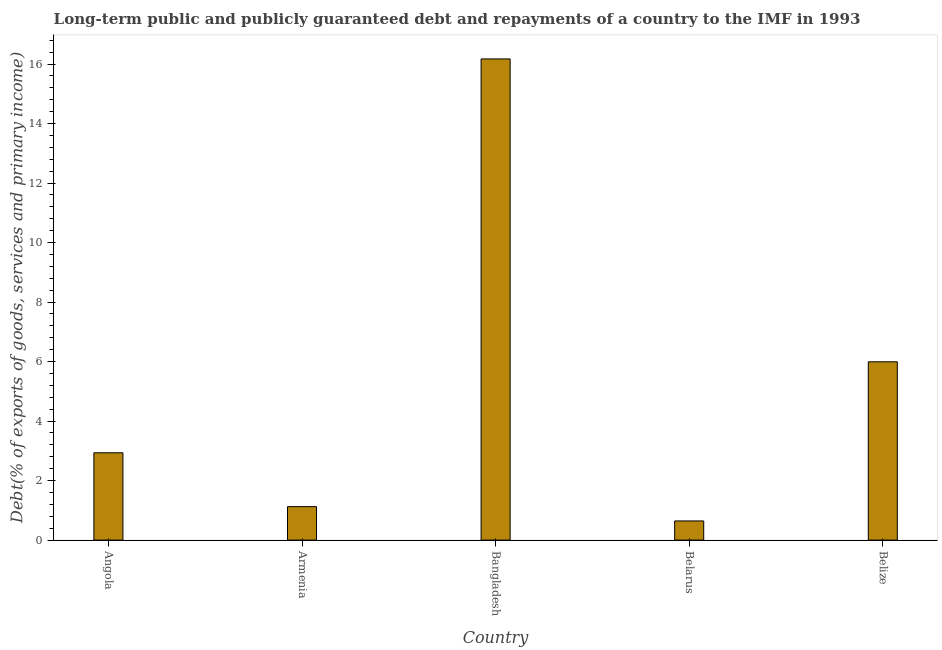What is the title of the graph?
Keep it short and to the point. Long-term public and publicly guaranteed debt and repayments of a country to the IMF in 1993. What is the label or title of the X-axis?
Offer a very short reply. Country. What is the label or title of the Y-axis?
Your answer should be very brief. Debt(% of exports of goods, services and primary income). What is the debt service in Belarus?
Give a very brief answer. 0.64. Across all countries, what is the maximum debt service?
Make the answer very short. 16.17. Across all countries, what is the minimum debt service?
Your answer should be compact. 0.64. In which country was the debt service minimum?
Provide a succinct answer. Belarus. What is the sum of the debt service?
Provide a succinct answer. 26.87. What is the difference between the debt service in Armenia and Belize?
Provide a short and direct response. -4.87. What is the average debt service per country?
Make the answer very short. 5.37. What is the median debt service?
Your response must be concise. 2.93. What is the ratio of the debt service in Angola to that in Belize?
Ensure brevity in your answer.  0.49. Is the debt service in Angola less than that in Armenia?
Offer a terse response. No. What is the difference between the highest and the second highest debt service?
Provide a short and direct response. 10.18. Is the sum of the debt service in Angola and Armenia greater than the maximum debt service across all countries?
Give a very brief answer. No. What is the difference between the highest and the lowest debt service?
Offer a terse response. 15.53. How many bars are there?
Offer a terse response. 5. Are all the bars in the graph horizontal?
Your answer should be compact. No. How many countries are there in the graph?
Provide a succinct answer. 5. Are the values on the major ticks of Y-axis written in scientific E-notation?
Offer a terse response. No. What is the Debt(% of exports of goods, services and primary income) in Angola?
Offer a very short reply. 2.93. What is the Debt(% of exports of goods, services and primary income) in Armenia?
Give a very brief answer. 1.12. What is the Debt(% of exports of goods, services and primary income) in Bangladesh?
Give a very brief answer. 16.17. What is the Debt(% of exports of goods, services and primary income) of Belarus?
Keep it short and to the point. 0.64. What is the Debt(% of exports of goods, services and primary income) in Belize?
Your response must be concise. 5.99. What is the difference between the Debt(% of exports of goods, services and primary income) in Angola and Armenia?
Offer a terse response. 1.81. What is the difference between the Debt(% of exports of goods, services and primary income) in Angola and Bangladesh?
Give a very brief answer. -13.24. What is the difference between the Debt(% of exports of goods, services and primary income) in Angola and Belarus?
Provide a succinct answer. 2.29. What is the difference between the Debt(% of exports of goods, services and primary income) in Angola and Belize?
Your response must be concise. -3.06. What is the difference between the Debt(% of exports of goods, services and primary income) in Armenia and Bangladesh?
Offer a terse response. -15.05. What is the difference between the Debt(% of exports of goods, services and primary income) in Armenia and Belarus?
Offer a very short reply. 0.48. What is the difference between the Debt(% of exports of goods, services and primary income) in Armenia and Belize?
Your response must be concise. -4.87. What is the difference between the Debt(% of exports of goods, services and primary income) in Bangladesh and Belarus?
Keep it short and to the point. 15.53. What is the difference between the Debt(% of exports of goods, services and primary income) in Bangladesh and Belize?
Give a very brief answer. 10.18. What is the difference between the Debt(% of exports of goods, services and primary income) in Belarus and Belize?
Make the answer very short. -5.35. What is the ratio of the Debt(% of exports of goods, services and primary income) in Angola to that in Armenia?
Provide a succinct answer. 2.61. What is the ratio of the Debt(% of exports of goods, services and primary income) in Angola to that in Bangladesh?
Make the answer very short. 0.18. What is the ratio of the Debt(% of exports of goods, services and primary income) in Angola to that in Belarus?
Give a very brief answer. 4.56. What is the ratio of the Debt(% of exports of goods, services and primary income) in Angola to that in Belize?
Your answer should be compact. 0.49. What is the ratio of the Debt(% of exports of goods, services and primary income) in Armenia to that in Bangladesh?
Your response must be concise. 0.07. What is the ratio of the Debt(% of exports of goods, services and primary income) in Armenia to that in Belarus?
Ensure brevity in your answer.  1.75. What is the ratio of the Debt(% of exports of goods, services and primary income) in Armenia to that in Belize?
Your answer should be compact. 0.19. What is the ratio of the Debt(% of exports of goods, services and primary income) in Bangladesh to that in Belarus?
Your answer should be compact. 25.11. What is the ratio of the Debt(% of exports of goods, services and primary income) in Bangladesh to that in Belize?
Your response must be concise. 2.7. What is the ratio of the Debt(% of exports of goods, services and primary income) in Belarus to that in Belize?
Provide a succinct answer. 0.11. 